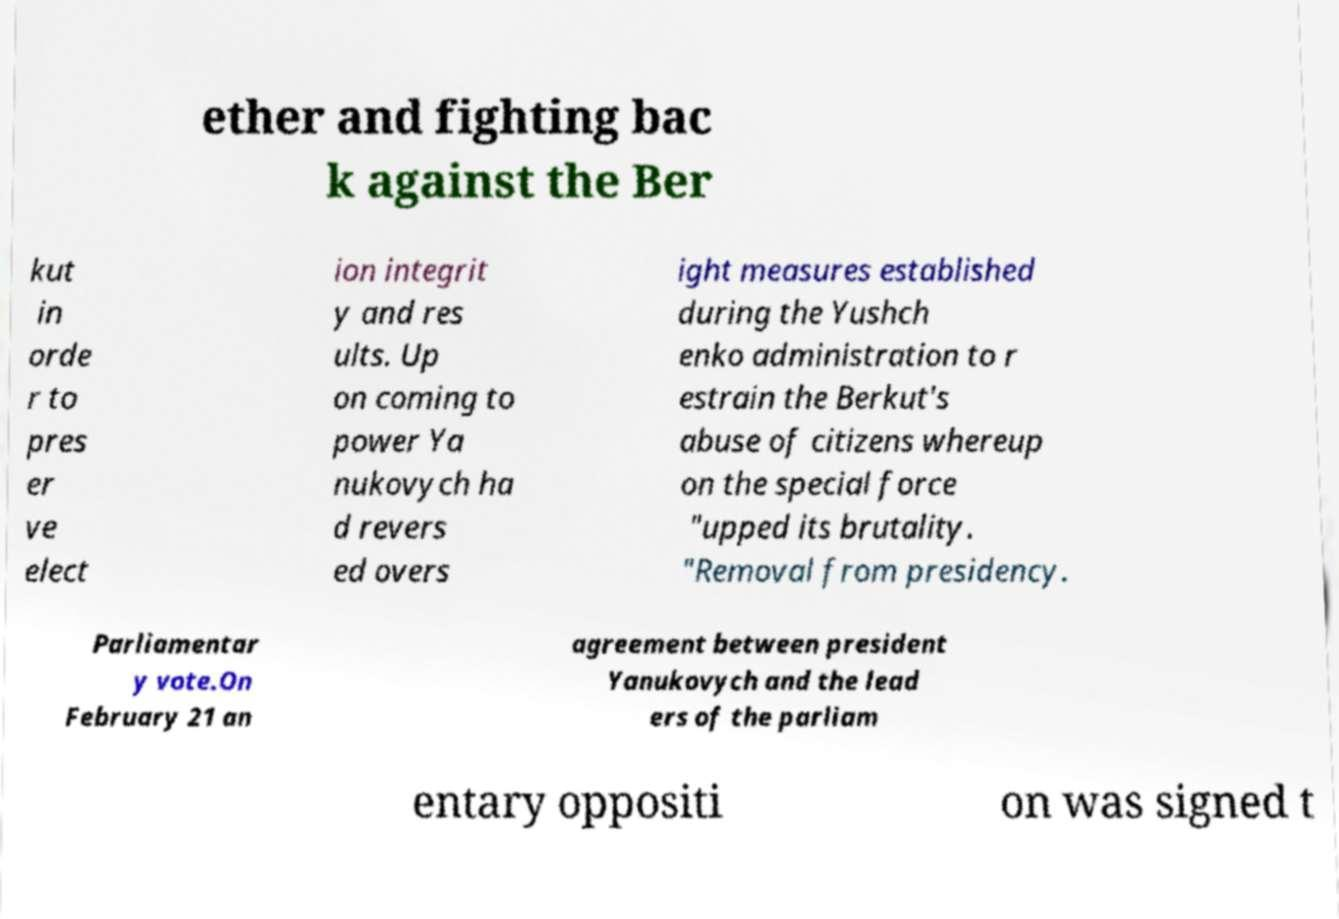There's text embedded in this image that I need extracted. Can you transcribe it verbatim? ether and fighting bac k against the Ber kut in orde r to pres er ve elect ion integrit y and res ults. Up on coming to power Ya nukovych ha d revers ed overs ight measures established during the Yushch enko administration to r estrain the Berkut's abuse of citizens whereup on the special force "upped its brutality. "Removal from presidency. Parliamentar y vote.On February 21 an agreement between president Yanukovych and the lead ers of the parliam entary oppositi on was signed t 